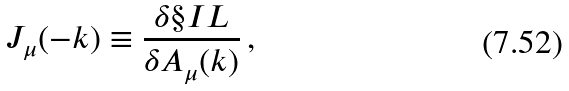<formula> <loc_0><loc_0><loc_500><loc_500>J _ { \mu } ( - k ) \equiv \frac { \delta \S I L } { \delta A _ { \mu } ( k ) } \, ,</formula> 